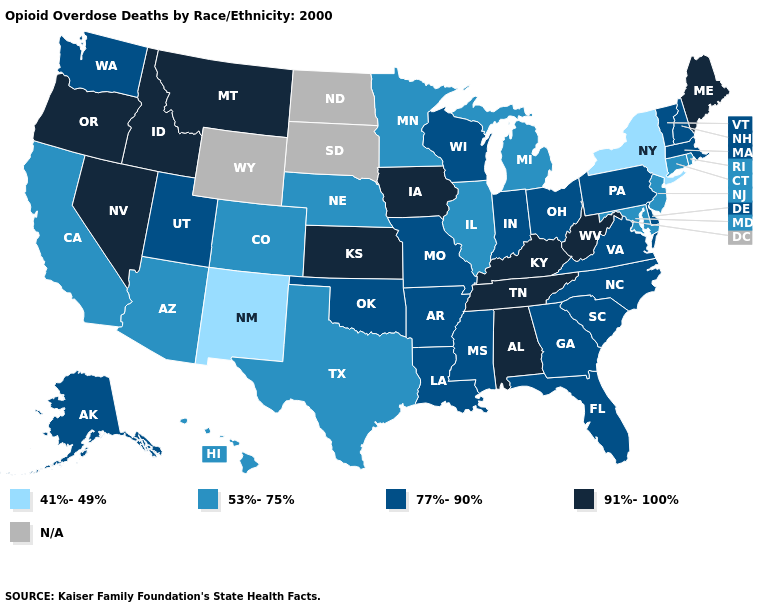Does Indiana have the lowest value in the USA?
Answer briefly. No. Which states have the lowest value in the USA?
Keep it brief. New Mexico, New York. Among the states that border Georgia , which have the lowest value?
Write a very short answer. Florida, North Carolina, South Carolina. Does Wisconsin have the highest value in the USA?
Be succinct. No. Among the states that border Kentucky , does Tennessee have the lowest value?
Concise answer only. No. Does Kentucky have the highest value in the USA?
Concise answer only. Yes. What is the lowest value in the USA?
Concise answer only. 41%-49%. Name the states that have a value in the range N/A?
Keep it brief. North Dakota, South Dakota, Wyoming. Name the states that have a value in the range 91%-100%?
Quick response, please. Alabama, Idaho, Iowa, Kansas, Kentucky, Maine, Montana, Nevada, Oregon, Tennessee, West Virginia. What is the value of Vermont?
Be succinct. 77%-90%. Name the states that have a value in the range 77%-90%?
Quick response, please. Alaska, Arkansas, Delaware, Florida, Georgia, Indiana, Louisiana, Massachusetts, Mississippi, Missouri, New Hampshire, North Carolina, Ohio, Oklahoma, Pennsylvania, South Carolina, Utah, Vermont, Virginia, Washington, Wisconsin. How many symbols are there in the legend?
Short answer required. 5. 